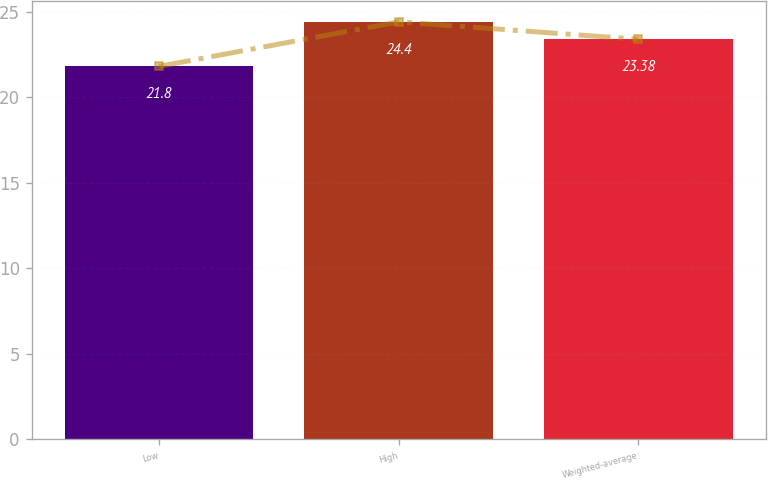Convert chart to OTSL. <chart><loc_0><loc_0><loc_500><loc_500><bar_chart><fcel>Low<fcel>High<fcel>Weighted-average<nl><fcel>21.8<fcel>24.4<fcel>23.38<nl></chart> 